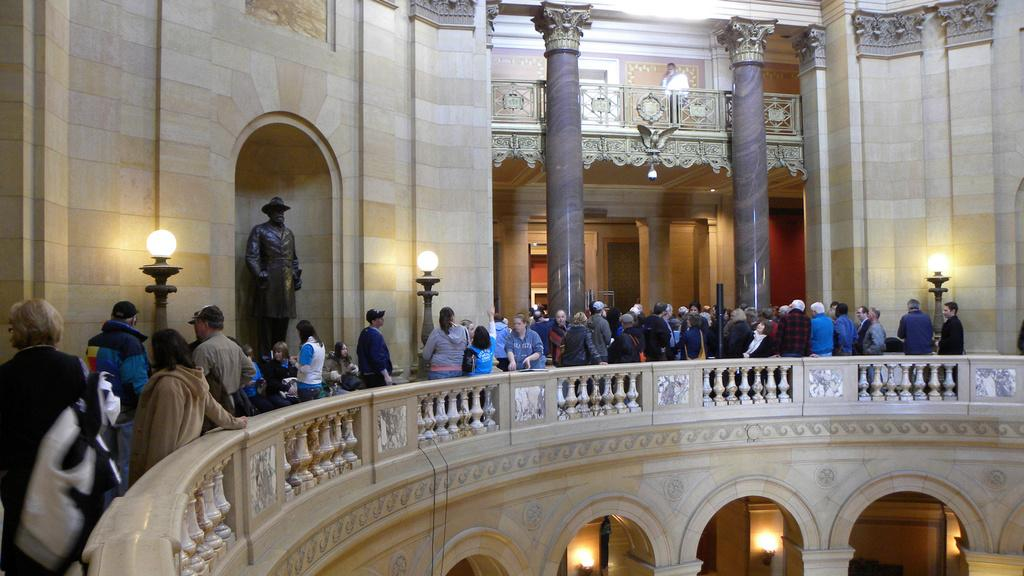What type of location is depicted in the image? The image shows the interior of a building. How many people can be seen in the image? There are many people in the image. What type of lighting is present in the image? There are many lamps in the image. What kind of artwork is featured in the image? There is a sculpture of a person in the image. What type of animal can be seen interacting with the sculpture in the image? There are no animals present in the image; it only features a sculpture of a person. 